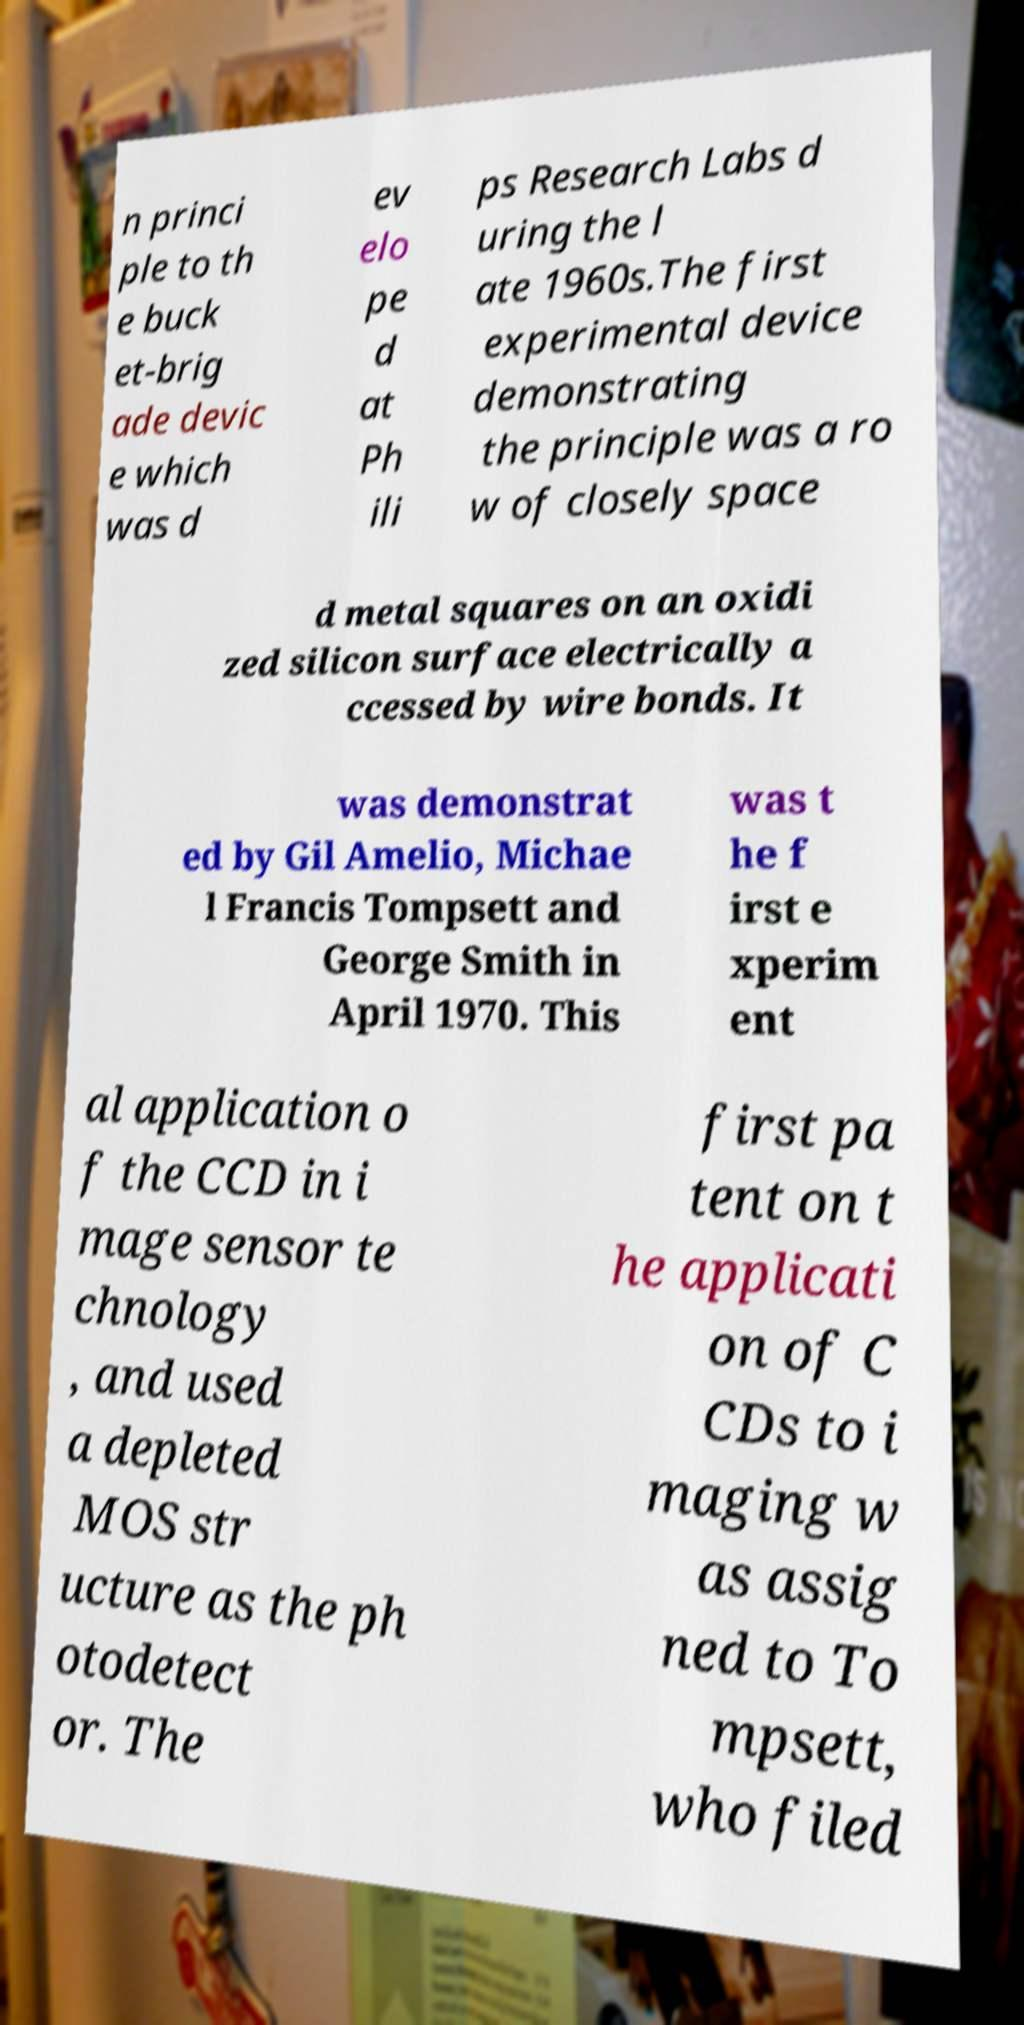Please read and relay the text visible in this image. What does it say? n princi ple to th e buck et-brig ade devic e which was d ev elo pe d at Ph ili ps Research Labs d uring the l ate 1960s.The first experimental device demonstrating the principle was a ro w of closely space d metal squares on an oxidi zed silicon surface electrically a ccessed by wire bonds. It was demonstrat ed by Gil Amelio, Michae l Francis Tompsett and George Smith in April 1970. This was t he f irst e xperim ent al application o f the CCD in i mage sensor te chnology , and used a depleted MOS str ucture as the ph otodetect or. The first pa tent on t he applicati on of C CDs to i maging w as assig ned to To mpsett, who filed 